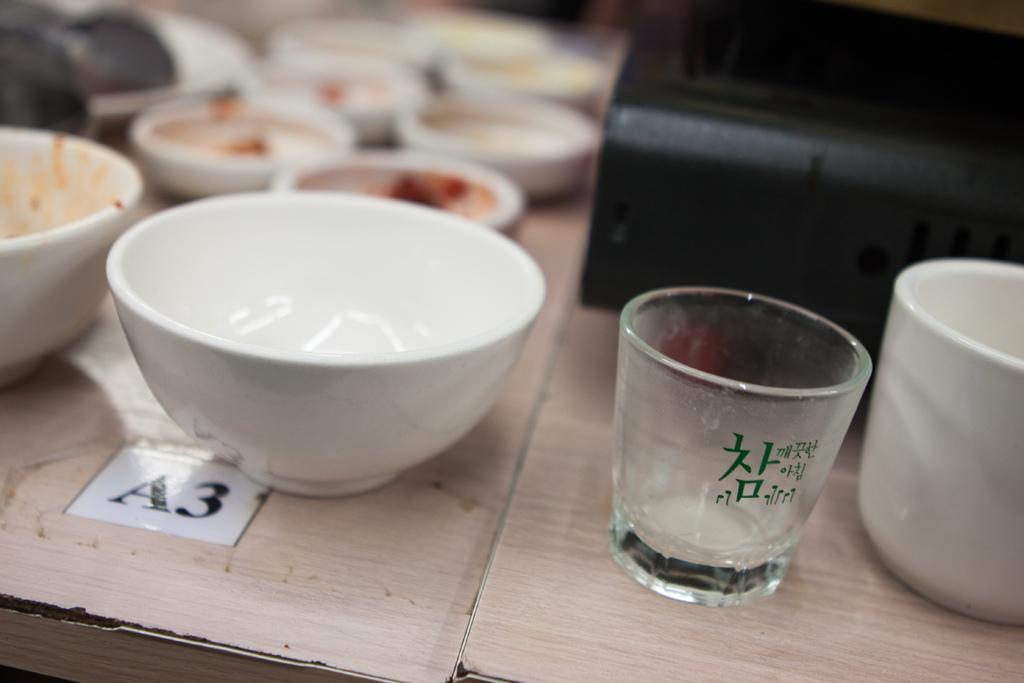Could you give a brief overview of what you see in this image? At the bottom of the image we can see tables and there are bowls, glass, cup and a toaster placed on the table. 